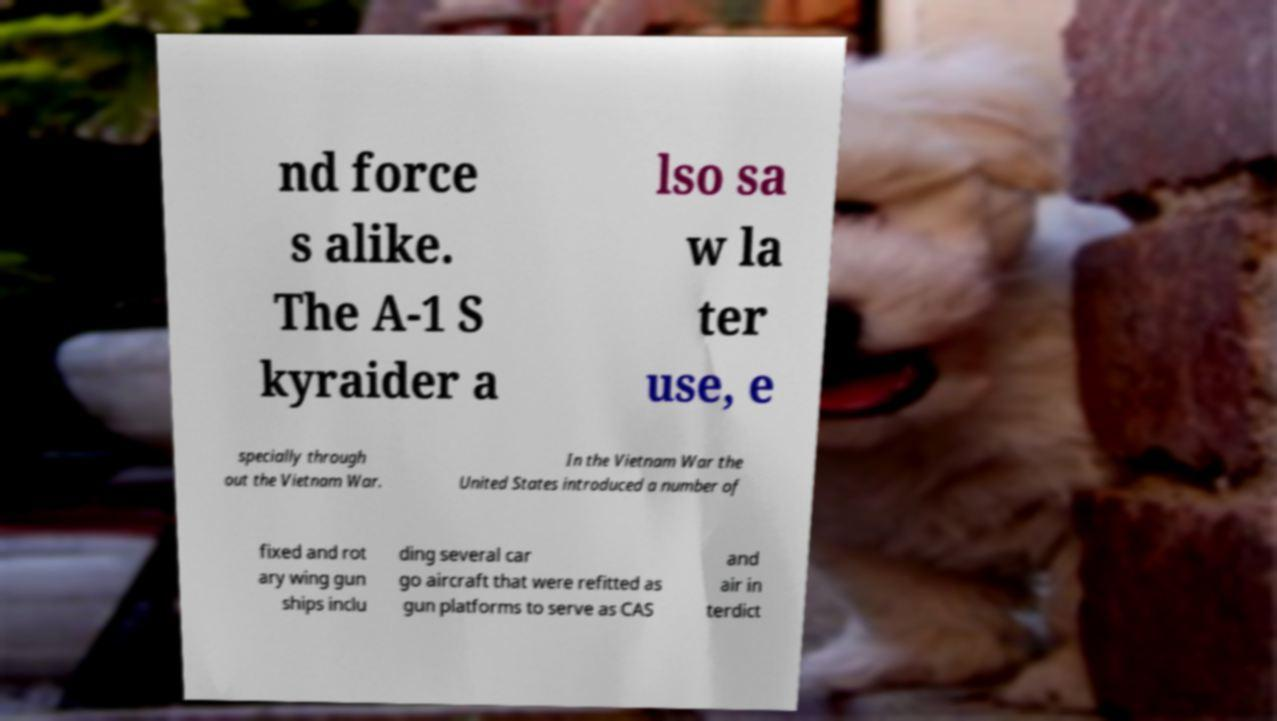Can you accurately transcribe the text from the provided image for me? nd force s alike. The A-1 S kyraider a lso sa w la ter use, e specially through out the Vietnam War. In the Vietnam War the United States introduced a number of fixed and rot ary wing gun ships inclu ding several car go aircraft that were refitted as gun platforms to serve as CAS and air in terdict 